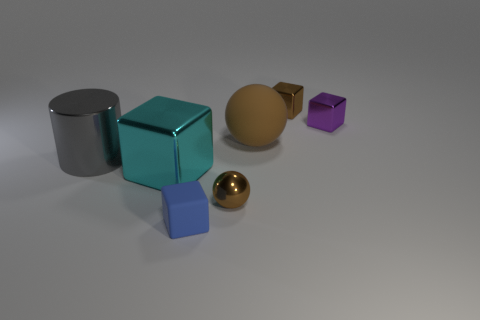Subtract all big shiny blocks. How many blocks are left? 3 Add 3 large purple objects. How many objects exist? 10 Subtract all brown cubes. How many cubes are left? 3 Subtract 1 balls. How many balls are left? 1 Subtract all blocks. How many objects are left? 3 Subtract 1 brown blocks. How many objects are left? 6 Subtract all red balls. Subtract all yellow cylinders. How many balls are left? 2 Subtract all small spheres. Subtract all gray metallic cylinders. How many objects are left? 5 Add 2 tiny rubber cubes. How many tiny rubber cubes are left? 3 Add 5 big balls. How many big balls exist? 6 